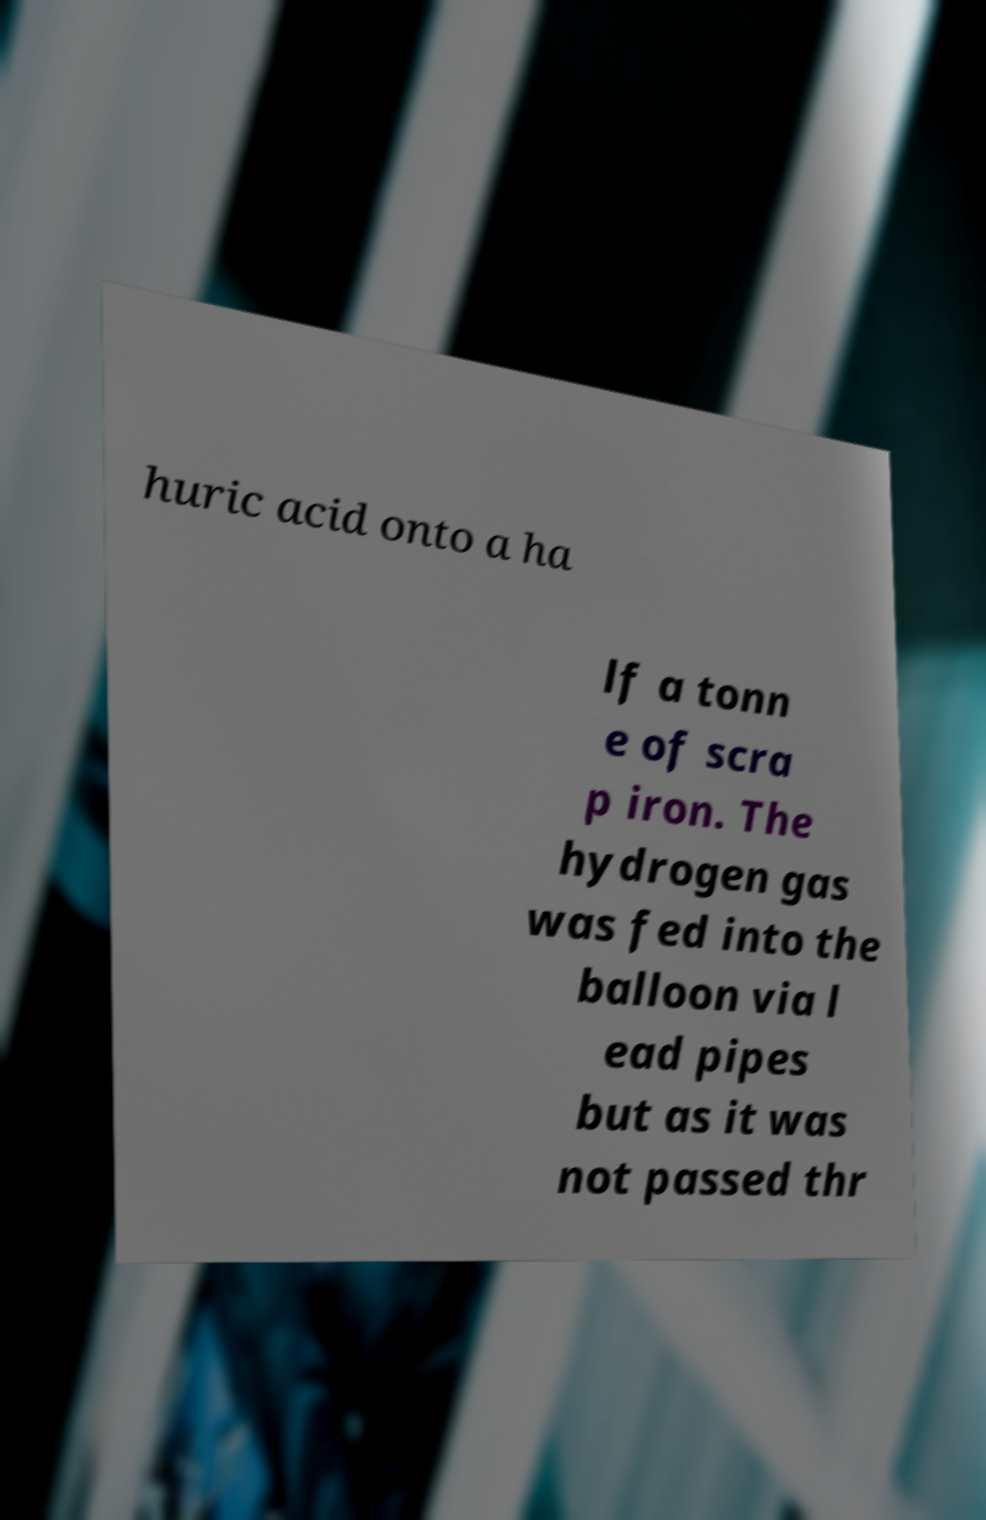I need the written content from this picture converted into text. Can you do that? huric acid onto a ha lf a tonn e of scra p iron. The hydrogen gas was fed into the balloon via l ead pipes but as it was not passed thr 